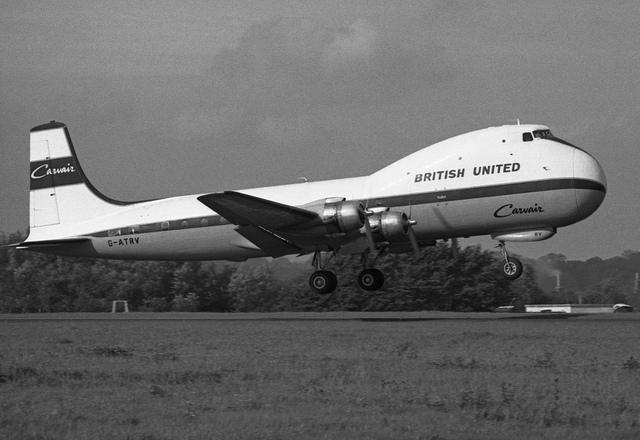How many propellers does the plane have?
Give a very brief answer. 4. How many airplanes are there?
Give a very brief answer. 1. 